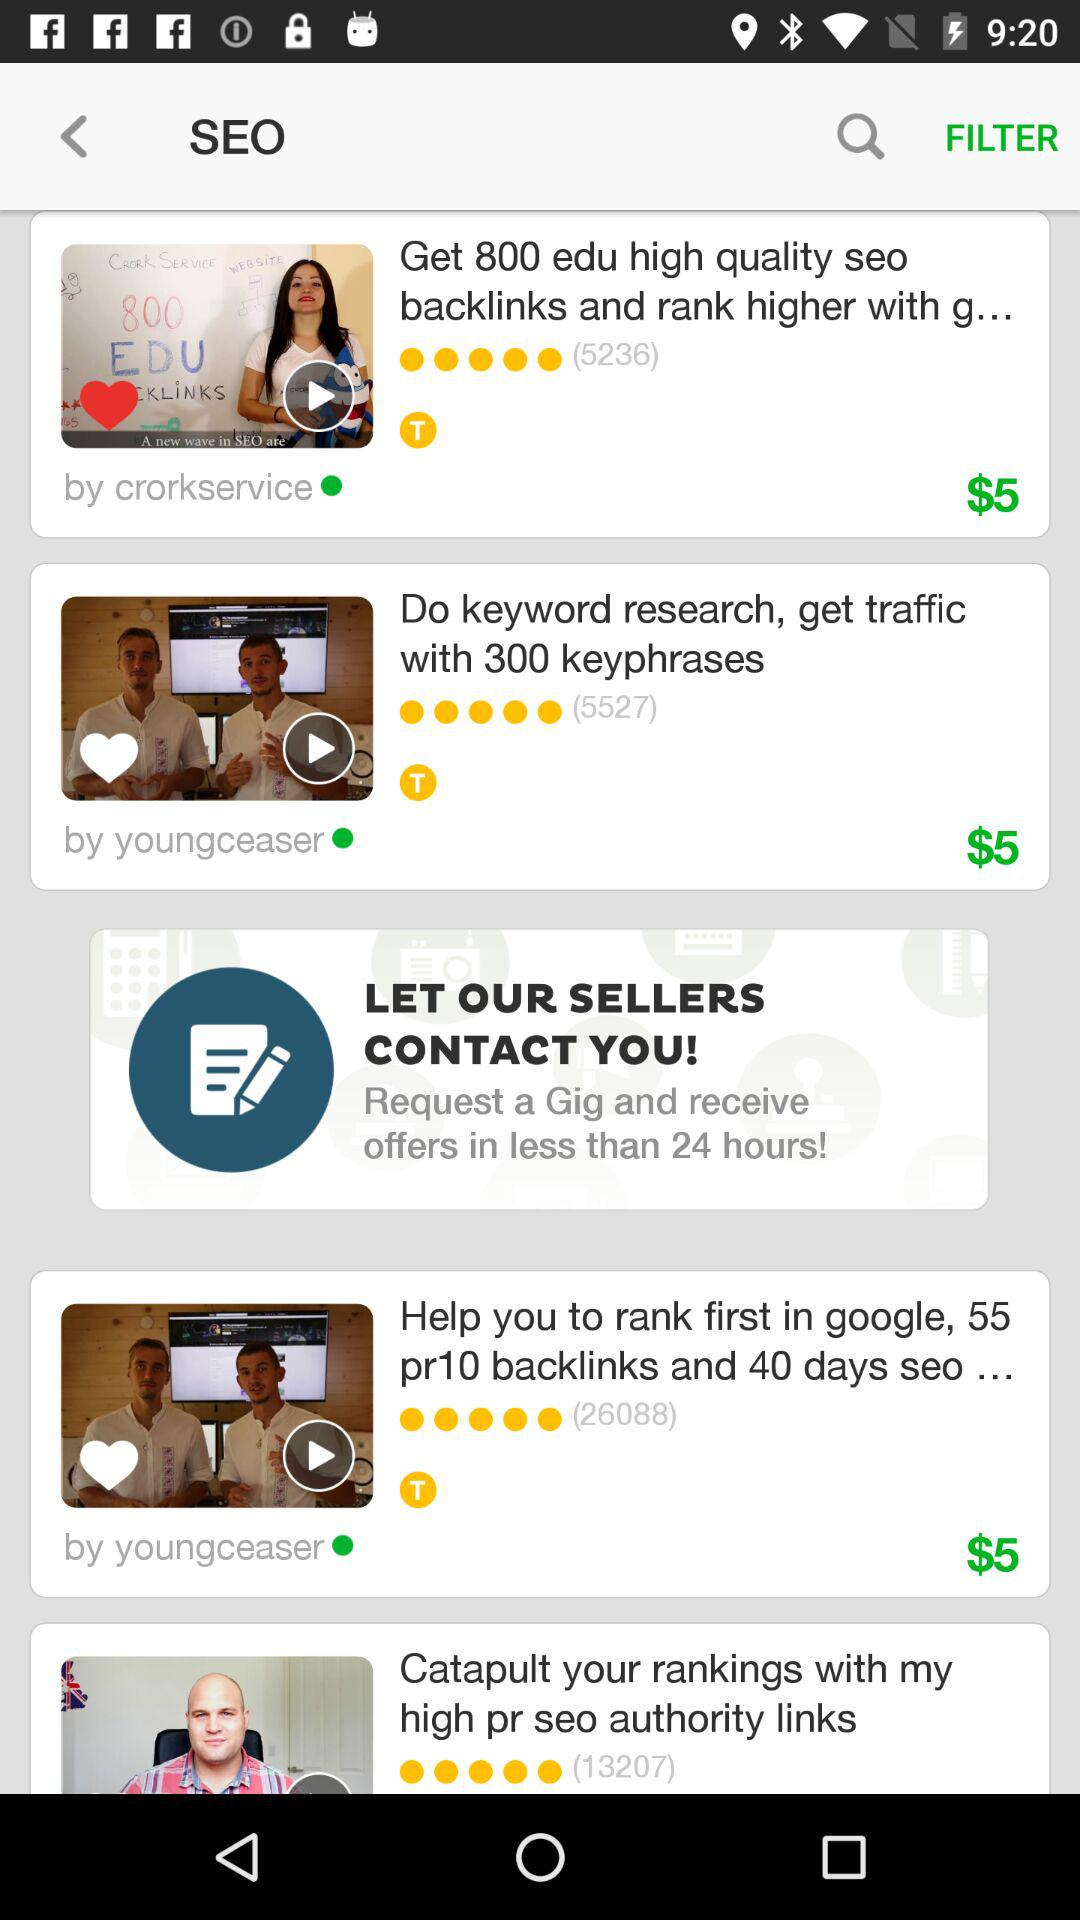How many reviews did "Do keyword research, get traffic with 300 keyphrases" get? There are 5527 reviews. 